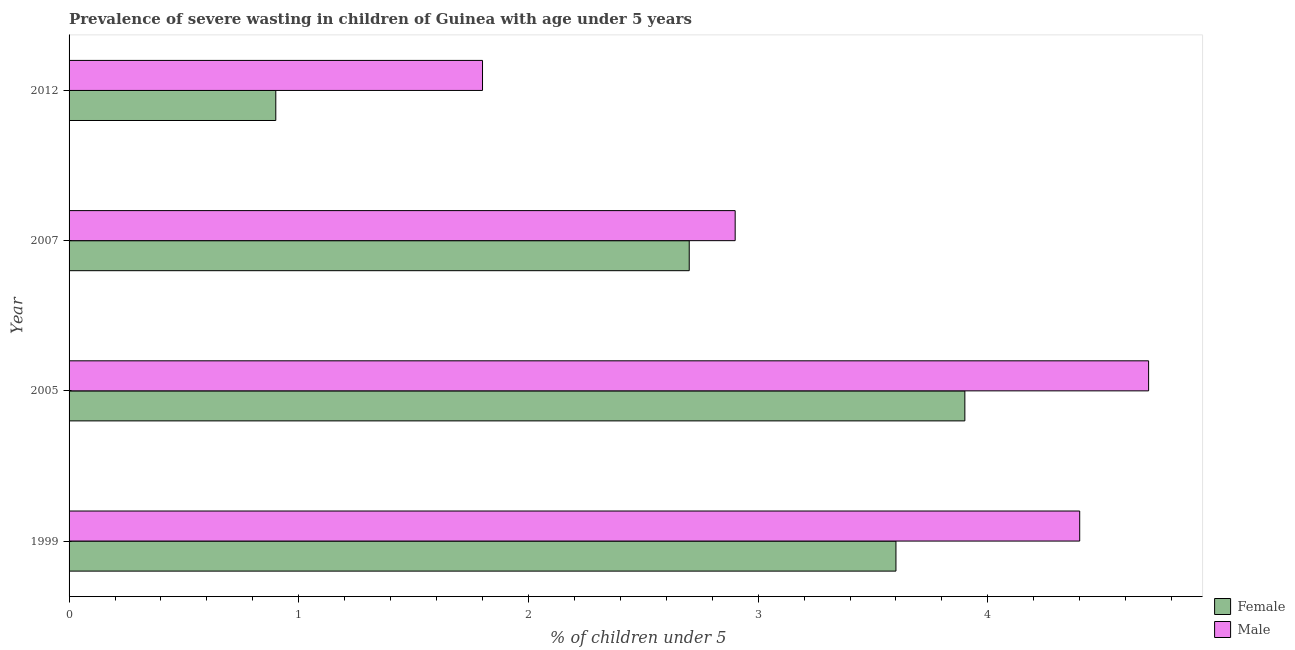How many different coloured bars are there?
Offer a terse response. 2. How many groups of bars are there?
Keep it short and to the point. 4. Are the number of bars per tick equal to the number of legend labels?
Ensure brevity in your answer.  Yes. What is the label of the 2nd group of bars from the top?
Keep it short and to the point. 2007. What is the percentage of undernourished female children in 2012?
Your response must be concise. 0.9. Across all years, what is the maximum percentage of undernourished male children?
Keep it short and to the point. 4.7. Across all years, what is the minimum percentage of undernourished male children?
Your response must be concise. 1.8. In which year was the percentage of undernourished female children minimum?
Your response must be concise. 2012. What is the total percentage of undernourished female children in the graph?
Provide a succinct answer. 11.1. What is the difference between the percentage of undernourished male children in 2005 and that in 2012?
Provide a succinct answer. 2.9. What is the difference between the percentage of undernourished male children in 2005 and the percentage of undernourished female children in 1999?
Provide a short and direct response. 1.1. What is the average percentage of undernourished female children per year?
Offer a terse response. 2.77. What is the ratio of the percentage of undernourished female children in 1999 to that in 2007?
Your response must be concise. 1.33. Is the difference between the percentage of undernourished female children in 1999 and 2005 greater than the difference between the percentage of undernourished male children in 1999 and 2005?
Your response must be concise. No. What is the difference between the highest and the second highest percentage of undernourished male children?
Give a very brief answer. 0.3. What is the difference between the highest and the lowest percentage of undernourished male children?
Provide a succinct answer. 2.9. Are the values on the major ticks of X-axis written in scientific E-notation?
Ensure brevity in your answer.  No. Does the graph contain any zero values?
Make the answer very short. No. How are the legend labels stacked?
Keep it short and to the point. Vertical. What is the title of the graph?
Give a very brief answer. Prevalence of severe wasting in children of Guinea with age under 5 years. What is the label or title of the X-axis?
Give a very brief answer.  % of children under 5. What is the  % of children under 5 of Female in 1999?
Your answer should be very brief. 3.6. What is the  % of children under 5 of Male in 1999?
Your answer should be compact. 4.4. What is the  % of children under 5 of Female in 2005?
Your answer should be compact. 3.9. What is the  % of children under 5 in Male in 2005?
Ensure brevity in your answer.  4.7. What is the  % of children under 5 in Female in 2007?
Offer a terse response. 2.7. What is the  % of children under 5 in Male in 2007?
Make the answer very short. 2.9. What is the  % of children under 5 of Female in 2012?
Provide a succinct answer. 0.9. What is the  % of children under 5 of Male in 2012?
Provide a succinct answer. 1.8. Across all years, what is the maximum  % of children under 5 of Female?
Provide a succinct answer. 3.9. Across all years, what is the maximum  % of children under 5 in Male?
Give a very brief answer. 4.7. Across all years, what is the minimum  % of children under 5 of Female?
Your answer should be compact. 0.9. Across all years, what is the minimum  % of children under 5 in Male?
Your response must be concise. 1.8. What is the total  % of children under 5 of Female in the graph?
Provide a short and direct response. 11.1. What is the total  % of children under 5 in Male in the graph?
Offer a terse response. 13.8. What is the difference between the  % of children under 5 of Female in 1999 and that in 2007?
Keep it short and to the point. 0.9. What is the difference between the  % of children under 5 of Female in 1999 and that in 2012?
Ensure brevity in your answer.  2.7. What is the difference between the  % of children under 5 in Female in 2005 and that in 2007?
Your answer should be compact. 1.2. What is the difference between the  % of children under 5 of Female in 2005 and that in 2012?
Offer a terse response. 3. What is the difference between the  % of children under 5 in Male in 2007 and that in 2012?
Your answer should be compact. 1.1. What is the difference between the  % of children under 5 in Female in 1999 and the  % of children under 5 in Male in 2007?
Your response must be concise. 0.7. What is the difference between the  % of children under 5 of Female in 1999 and the  % of children under 5 of Male in 2012?
Provide a short and direct response. 1.8. What is the difference between the  % of children under 5 of Female in 2005 and the  % of children under 5 of Male in 2007?
Give a very brief answer. 1. What is the difference between the  % of children under 5 in Female in 2007 and the  % of children under 5 in Male in 2012?
Your response must be concise. 0.9. What is the average  % of children under 5 of Female per year?
Offer a terse response. 2.77. What is the average  % of children under 5 of Male per year?
Make the answer very short. 3.45. In the year 2005, what is the difference between the  % of children under 5 of Female and  % of children under 5 of Male?
Your answer should be compact. -0.8. In the year 2007, what is the difference between the  % of children under 5 in Female and  % of children under 5 in Male?
Provide a succinct answer. -0.2. What is the ratio of the  % of children under 5 of Male in 1999 to that in 2005?
Ensure brevity in your answer.  0.94. What is the ratio of the  % of children under 5 of Male in 1999 to that in 2007?
Your response must be concise. 1.52. What is the ratio of the  % of children under 5 of Male in 1999 to that in 2012?
Give a very brief answer. 2.44. What is the ratio of the  % of children under 5 in Female in 2005 to that in 2007?
Offer a terse response. 1.44. What is the ratio of the  % of children under 5 in Male in 2005 to that in 2007?
Provide a short and direct response. 1.62. What is the ratio of the  % of children under 5 of Female in 2005 to that in 2012?
Provide a short and direct response. 4.33. What is the ratio of the  % of children under 5 of Male in 2005 to that in 2012?
Keep it short and to the point. 2.61. What is the ratio of the  % of children under 5 of Female in 2007 to that in 2012?
Your response must be concise. 3. What is the ratio of the  % of children under 5 of Male in 2007 to that in 2012?
Make the answer very short. 1.61. What is the difference between the highest and the lowest  % of children under 5 of Female?
Keep it short and to the point. 3. What is the difference between the highest and the lowest  % of children under 5 of Male?
Offer a terse response. 2.9. 